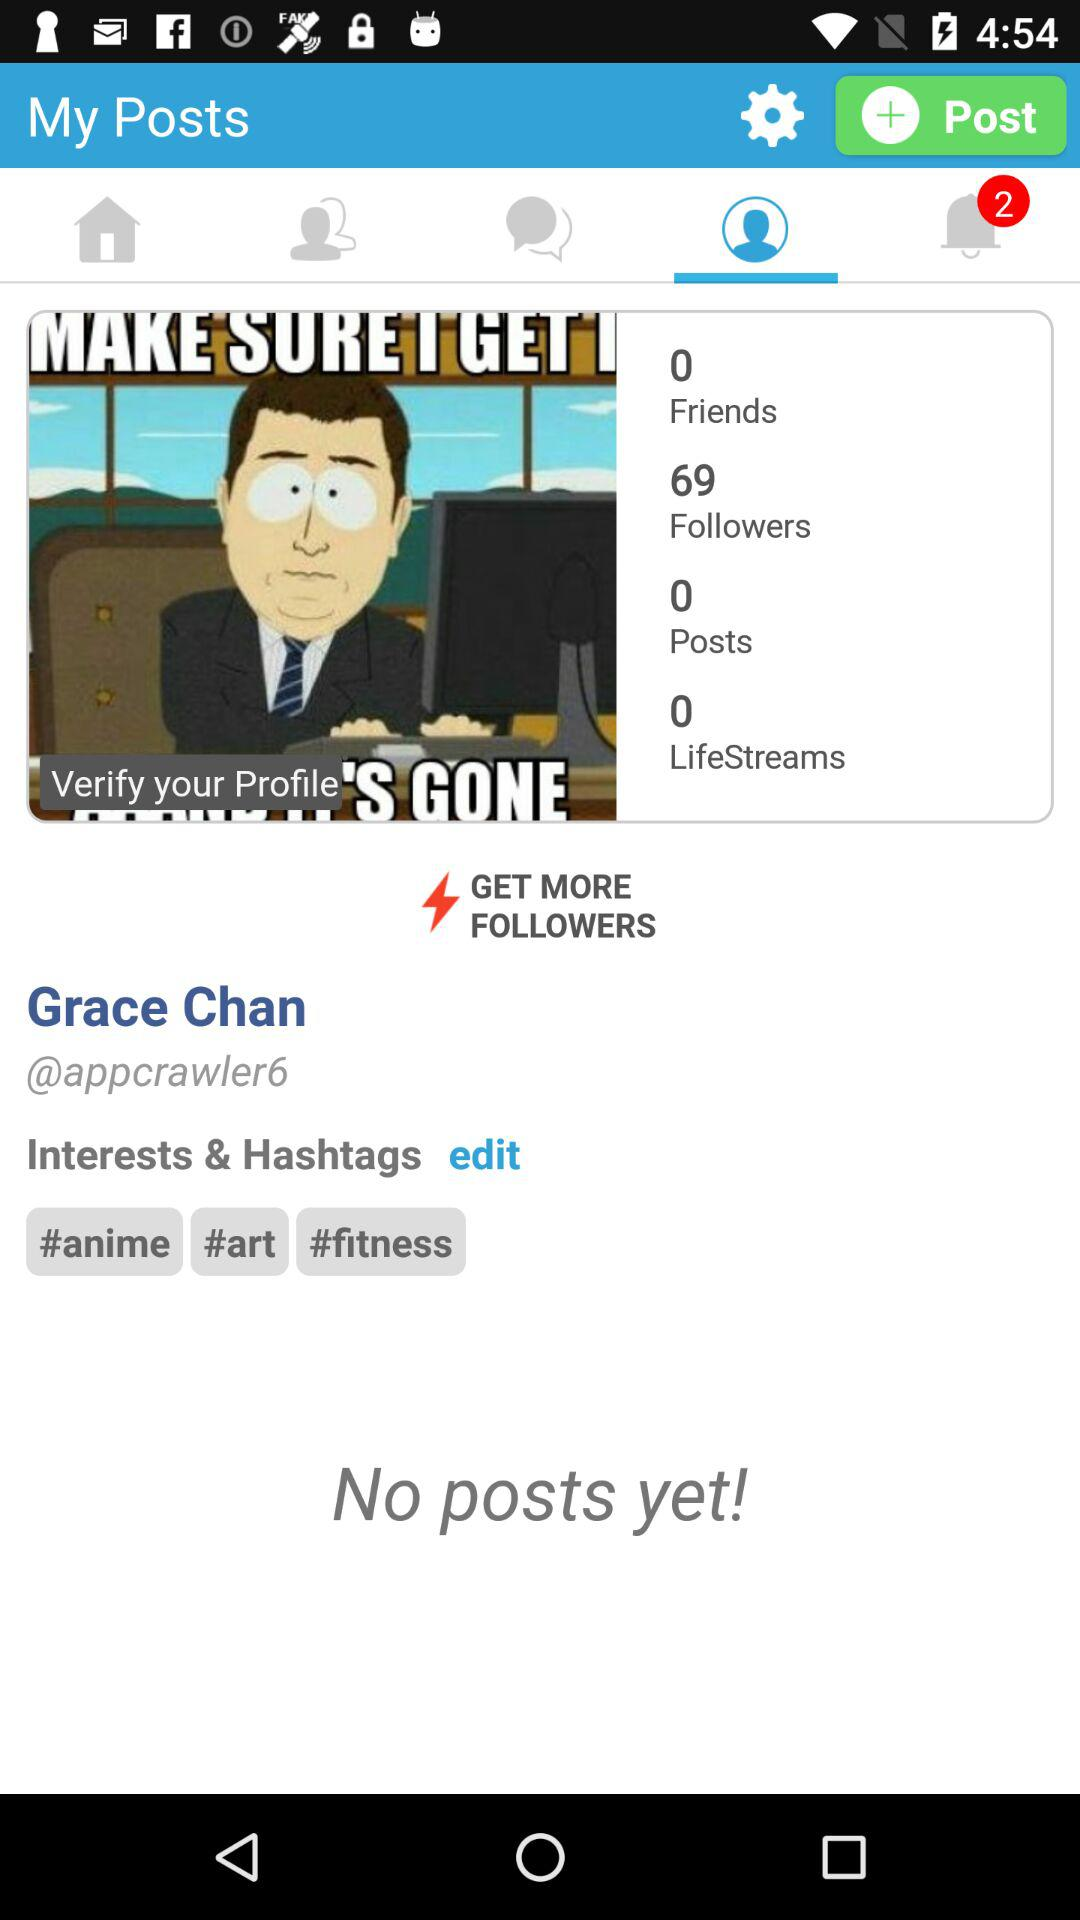How many unread notifications are shown here? There are 2 unread notifications. 